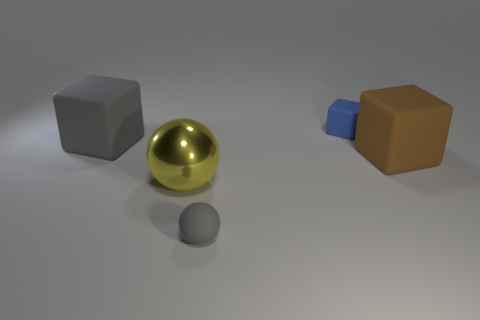What number of matte things are either small gray things or brown cubes?
Make the answer very short. 2. Are there any yellow spheres made of the same material as the blue thing?
Provide a short and direct response. No. What number of objects are either gray things that are in front of the large metal thing or things to the left of the tiny blue matte object?
Your answer should be compact. 3. Do the matte thing in front of the brown rubber thing and the large shiny object have the same color?
Make the answer very short. No. How many other objects are the same color as the big metal object?
Your response must be concise. 0. What is the material of the big ball?
Your answer should be very brief. Metal. There is a matte object on the left side of the gray ball; is its size the same as the gray sphere?
Provide a short and direct response. No. Is there anything else that has the same size as the brown thing?
Your response must be concise. Yes. What is the size of the rubber thing that is the same shape as the yellow metallic thing?
Ensure brevity in your answer.  Small. Are there an equal number of rubber cubes that are to the right of the large yellow metal object and tiny blocks to the right of the big gray rubber object?
Your answer should be very brief. No. 